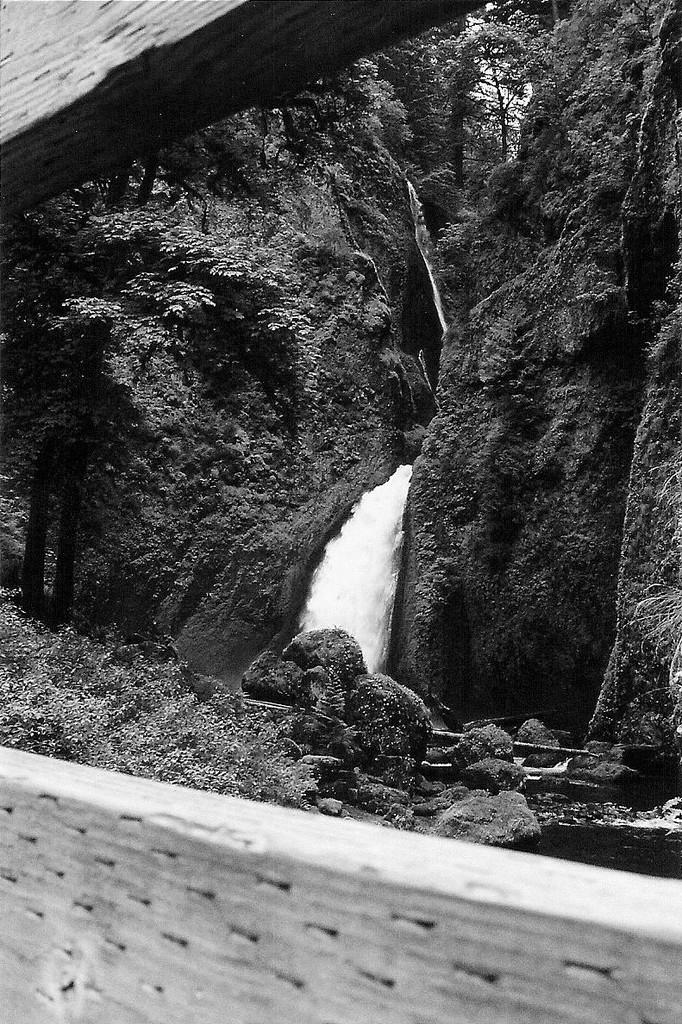What type of barrier is in the image? There is a wooden fence in the image. What can be seen through the wooden fence? A waterfall is visible through the wooden fence. What type of vegetation is near the waterfall? There are trees beside the waterfall. What else is present near the waterfall? Rocks are present beside the waterfall. How many women are using the drug in the image? There are no women or drugs present in the image. 